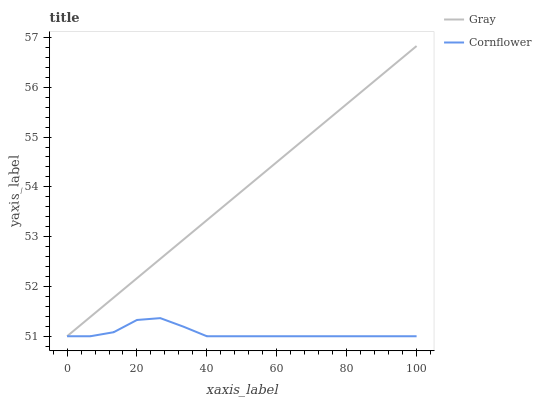Does Cornflower have the maximum area under the curve?
Answer yes or no. No. Is Cornflower the smoothest?
Answer yes or no. No. Does Cornflower have the highest value?
Answer yes or no. No. 